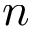Convert formula to latex. <formula><loc_0><loc_0><loc_500><loc_500>n</formula> 